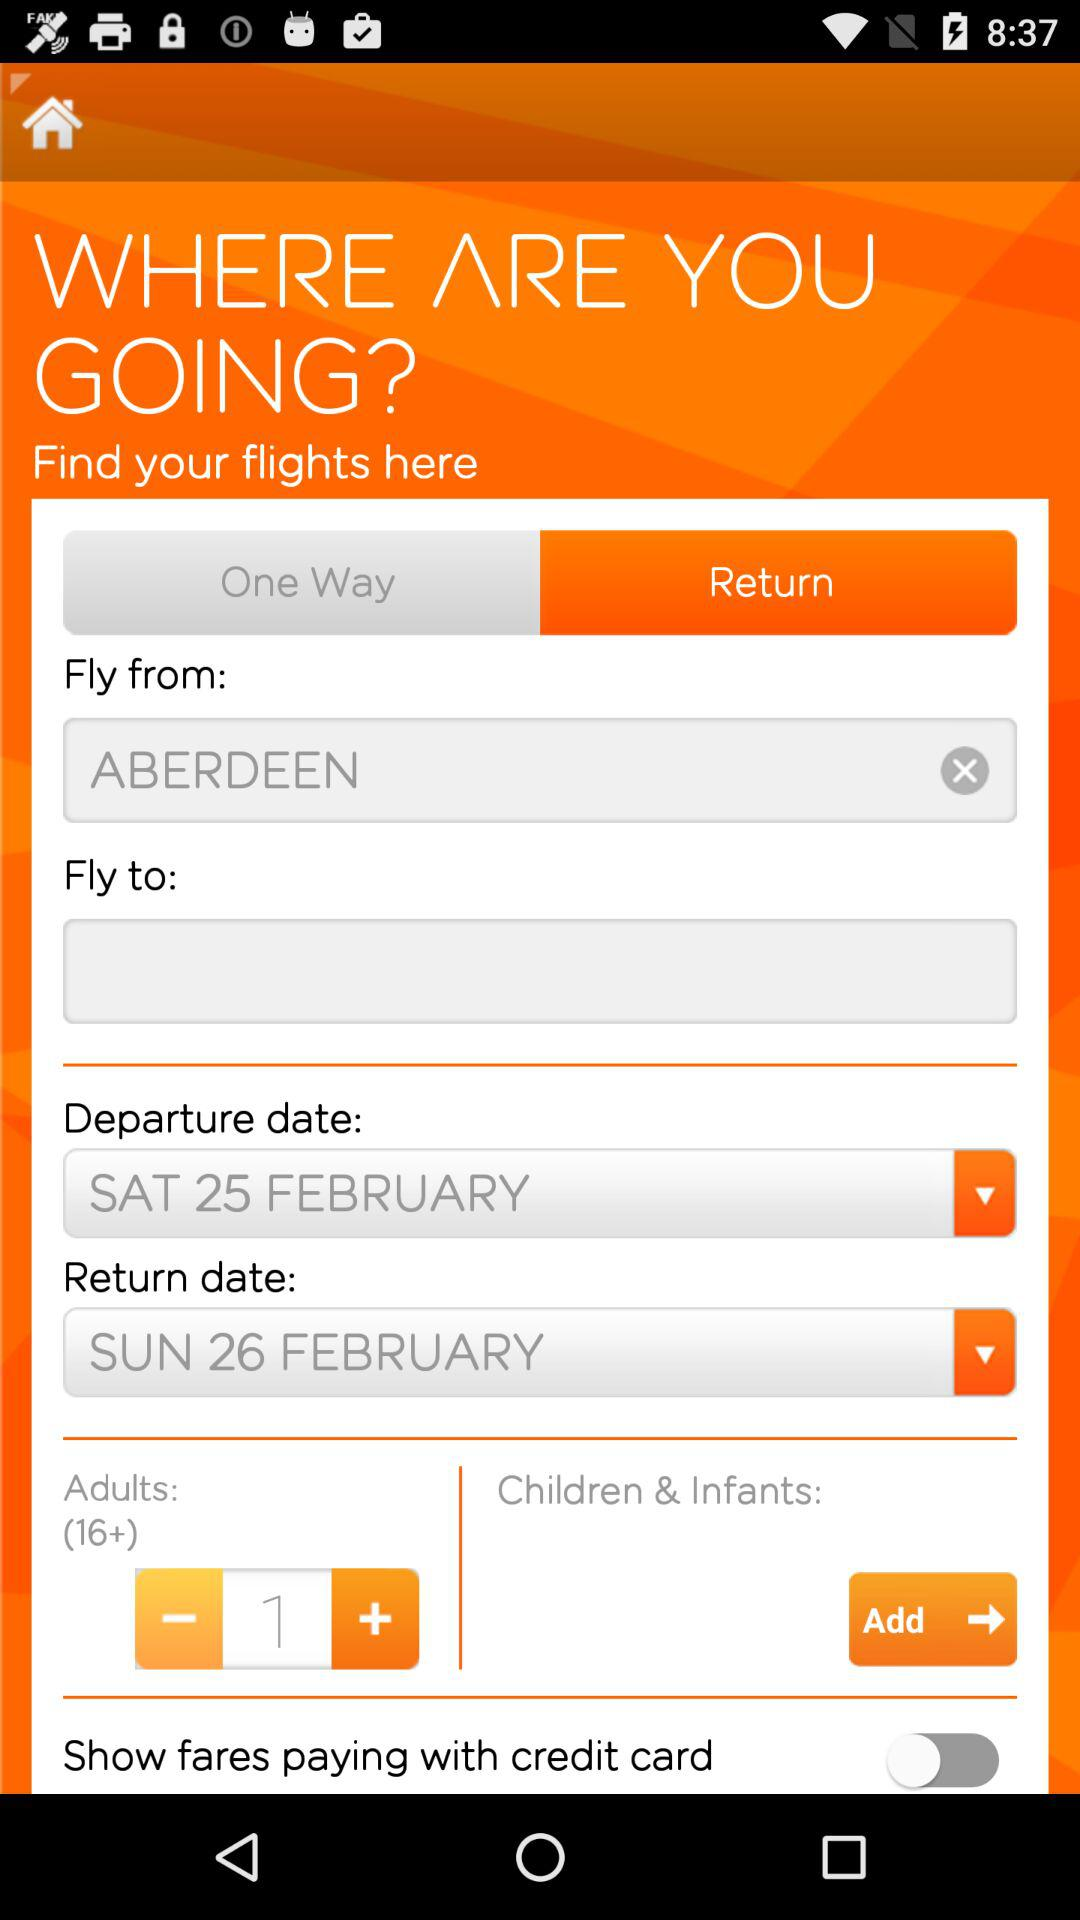Where are we flying to?
When the provided information is insufficient, respond with <no answer>. <no answer> 